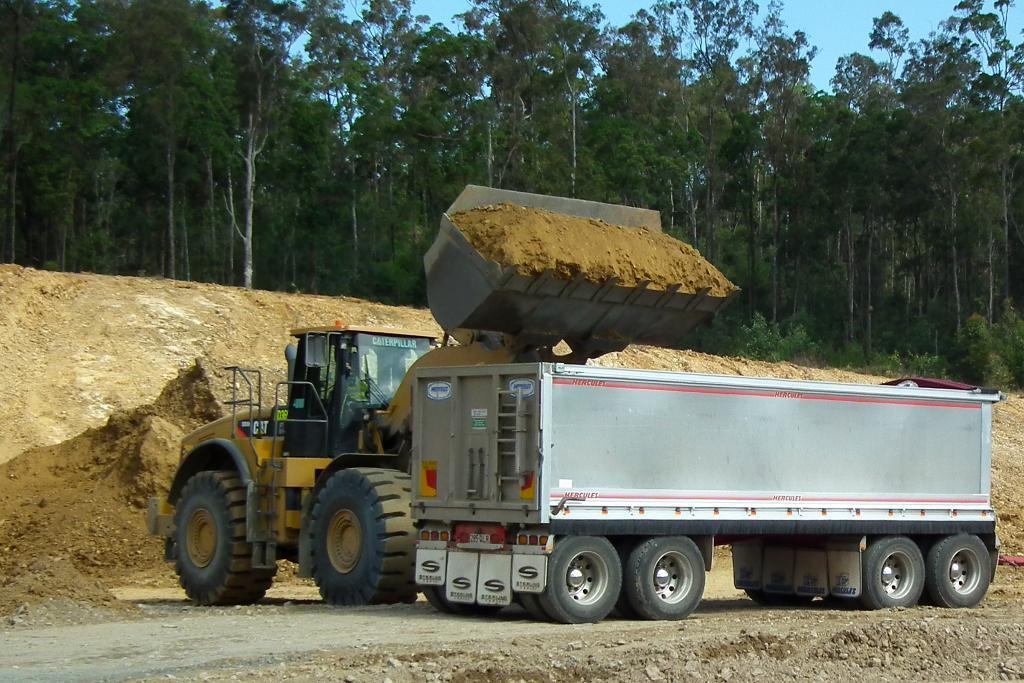Where was the picture taken? The picture was clicked outside. What is the main subject in the center of the image? There is a crane and a vehicle in the center of the image. What can be seen in the background of the image? There is sand, the sky, and trees visible in the background of the image. What day of the week is depicted in the image? The image does not depict a specific day of the week; it is a still photograph. Can you see a snail crawling on the crane in the image? There is no snail visible in the image; it only features a crane and a vehicle. 